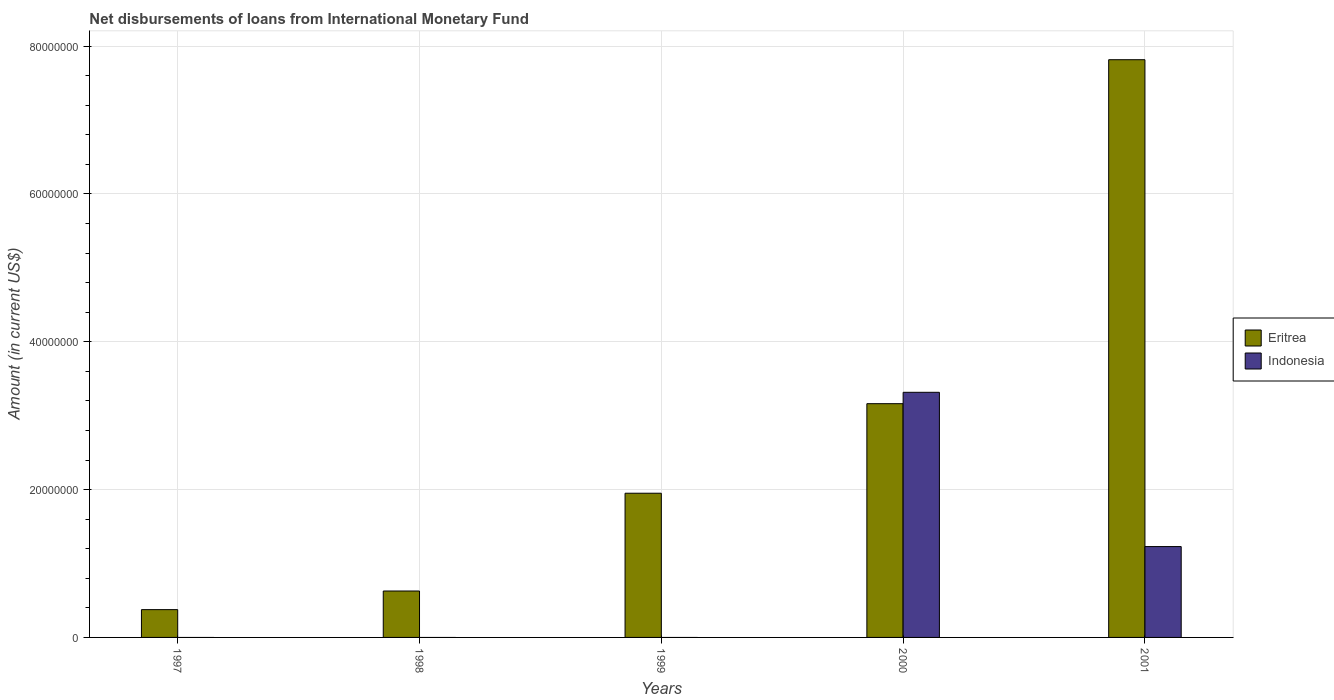How many different coloured bars are there?
Your answer should be very brief. 2. How many bars are there on the 5th tick from the left?
Provide a succinct answer. 2. How many bars are there on the 2nd tick from the right?
Your response must be concise. 2. Across all years, what is the maximum amount of loans disbursed in Indonesia?
Make the answer very short. 3.32e+07. In which year was the amount of loans disbursed in Eritrea maximum?
Your response must be concise. 2001. What is the total amount of loans disbursed in Indonesia in the graph?
Offer a terse response. 4.54e+07. What is the difference between the amount of loans disbursed in Eritrea in 1997 and that in 2000?
Your answer should be very brief. -2.79e+07. What is the difference between the amount of loans disbursed in Eritrea in 1997 and the amount of loans disbursed in Indonesia in 1999?
Your answer should be compact. 3.76e+06. What is the average amount of loans disbursed in Eritrea per year?
Offer a terse response. 2.79e+07. In the year 2000, what is the difference between the amount of loans disbursed in Eritrea and amount of loans disbursed in Indonesia?
Ensure brevity in your answer.  -1.54e+06. In how many years, is the amount of loans disbursed in Indonesia greater than 12000000 US$?
Keep it short and to the point. 2. What is the ratio of the amount of loans disbursed in Indonesia in 2000 to that in 2001?
Give a very brief answer. 2.7. Is the amount of loans disbursed in Eritrea in 1998 less than that in 1999?
Your response must be concise. Yes. What is the difference between the highest and the second highest amount of loans disbursed in Eritrea?
Ensure brevity in your answer.  4.65e+07. What is the difference between the highest and the lowest amount of loans disbursed in Eritrea?
Provide a short and direct response. 7.44e+07. Is the sum of the amount of loans disbursed in Eritrea in 1997 and 1998 greater than the maximum amount of loans disbursed in Indonesia across all years?
Provide a short and direct response. No. Does the graph contain any zero values?
Offer a very short reply. Yes. Where does the legend appear in the graph?
Ensure brevity in your answer.  Center right. How many legend labels are there?
Provide a short and direct response. 2. What is the title of the graph?
Keep it short and to the point. Net disbursements of loans from International Monetary Fund. Does "Benin" appear as one of the legend labels in the graph?
Provide a succinct answer. No. What is the label or title of the X-axis?
Your answer should be very brief. Years. What is the label or title of the Y-axis?
Offer a very short reply. Amount (in current US$). What is the Amount (in current US$) of Eritrea in 1997?
Your response must be concise. 3.76e+06. What is the Amount (in current US$) in Eritrea in 1998?
Offer a terse response. 6.28e+06. What is the Amount (in current US$) of Eritrea in 1999?
Your response must be concise. 1.95e+07. What is the Amount (in current US$) in Indonesia in 1999?
Provide a succinct answer. 0. What is the Amount (in current US$) in Eritrea in 2000?
Your response must be concise. 3.16e+07. What is the Amount (in current US$) in Indonesia in 2000?
Offer a terse response. 3.32e+07. What is the Amount (in current US$) of Eritrea in 2001?
Provide a short and direct response. 7.82e+07. What is the Amount (in current US$) of Indonesia in 2001?
Offer a terse response. 1.23e+07. Across all years, what is the maximum Amount (in current US$) of Eritrea?
Ensure brevity in your answer.  7.82e+07. Across all years, what is the maximum Amount (in current US$) of Indonesia?
Your response must be concise. 3.32e+07. Across all years, what is the minimum Amount (in current US$) in Eritrea?
Provide a short and direct response. 3.76e+06. Across all years, what is the minimum Amount (in current US$) in Indonesia?
Your response must be concise. 0. What is the total Amount (in current US$) in Eritrea in the graph?
Keep it short and to the point. 1.39e+08. What is the total Amount (in current US$) in Indonesia in the graph?
Keep it short and to the point. 4.54e+07. What is the difference between the Amount (in current US$) of Eritrea in 1997 and that in 1998?
Your answer should be very brief. -2.52e+06. What is the difference between the Amount (in current US$) in Eritrea in 1997 and that in 1999?
Keep it short and to the point. -1.57e+07. What is the difference between the Amount (in current US$) of Eritrea in 1997 and that in 2000?
Your answer should be compact. -2.79e+07. What is the difference between the Amount (in current US$) in Eritrea in 1997 and that in 2001?
Provide a succinct answer. -7.44e+07. What is the difference between the Amount (in current US$) of Eritrea in 1998 and that in 1999?
Ensure brevity in your answer.  -1.32e+07. What is the difference between the Amount (in current US$) of Eritrea in 1998 and that in 2000?
Provide a short and direct response. -2.53e+07. What is the difference between the Amount (in current US$) in Eritrea in 1998 and that in 2001?
Your response must be concise. -7.19e+07. What is the difference between the Amount (in current US$) in Eritrea in 1999 and that in 2000?
Your response must be concise. -1.21e+07. What is the difference between the Amount (in current US$) of Eritrea in 1999 and that in 2001?
Your answer should be very brief. -5.86e+07. What is the difference between the Amount (in current US$) of Eritrea in 2000 and that in 2001?
Your answer should be very brief. -4.65e+07. What is the difference between the Amount (in current US$) in Indonesia in 2000 and that in 2001?
Your response must be concise. 2.09e+07. What is the difference between the Amount (in current US$) of Eritrea in 1997 and the Amount (in current US$) of Indonesia in 2000?
Ensure brevity in your answer.  -2.94e+07. What is the difference between the Amount (in current US$) in Eritrea in 1997 and the Amount (in current US$) in Indonesia in 2001?
Your answer should be very brief. -8.53e+06. What is the difference between the Amount (in current US$) in Eritrea in 1998 and the Amount (in current US$) in Indonesia in 2000?
Make the answer very short. -2.69e+07. What is the difference between the Amount (in current US$) in Eritrea in 1998 and the Amount (in current US$) in Indonesia in 2001?
Your response must be concise. -6.01e+06. What is the difference between the Amount (in current US$) in Eritrea in 1999 and the Amount (in current US$) in Indonesia in 2000?
Offer a terse response. -1.37e+07. What is the difference between the Amount (in current US$) of Eritrea in 1999 and the Amount (in current US$) of Indonesia in 2001?
Your response must be concise. 7.22e+06. What is the difference between the Amount (in current US$) in Eritrea in 2000 and the Amount (in current US$) in Indonesia in 2001?
Your answer should be very brief. 1.93e+07. What is the average Amount (in current US$) in Eritrea per year?
Your response must be concise. 2.79e+07. What is the average Amount (in current US$) in Indonesia per year?
Offer a terse response. 9.09e+06. In the year 2000, what is the difference between the Amount (in current US$) of Eritrea and Amount (in current US$) of Indonesia?
Make the answer very short. -1.54e+06. In the year 2001, what is the difference between the Amount (in current US$) of Eritrea and Amount (in current US$) of Indonesia?
Your response must be concise. 6.59e+07. What is the ratio of the Amount (in current US$) of Eritrea in 1997 to that in 1998?
Give a very brief answer. 0.6. What is the ratio of the Amount (in current US$) in Eritrea in 1997 to that in 1999?
Your answer should be very brief. 0.19. What is the ratio of the Amount (in current US$) of Eritrea in 1997 to that in 2000?
Your answer should be compact. 0.12. What is the ratio of the Amount (in current US$) in Eritrea in 1997 to that in 2001?
Your answer should be very brief. 0.05. What is the ratio of the Amount (in current US$) of Eritrea in 1998 to that in 1999?
Your answer should be very brief. 0.32. What is the ratio of the Amount (in current US$) in Eritrea in 1998 to that in 2000?
Your answer should be very brief. 0.2. What is the ratio of the Amount (in current US$) of Eritrea in 1998 to that in 2001?
Provide a succinct answer. 0.08. What is the ratio of the Amount (in current US$) of Eritrea in 1999 to that in 2000?
Offer a terse response. 0.62. What is the ratio of the Amount (in current US$) of Eritrea in 1999 to that in 2001?
Offer a terse response. 0.25. What is the ratio of the Amount (in current US$) in Eritrea in 2000 to that in 2001?
Ensure brevity in your answer.  0.4. What is the ratio of the Amount (in current US$) of Indonesia in 2000 to that in 2001?
Offer a terse response. 2.7. What is the difference between the highest and the second highest Amount (in current US$) in Eritrea?
Offer a terse response. 4.65e+07. What is the difference between the highest and the lowest Amount (in current US$) of Eritrea?
Provide a short and direct response. 7.44e+07. What is the difference between the highest and the lowest Amount (in current US$) of Indonesia?
Provide a short and direct response. 3.32e+07. 